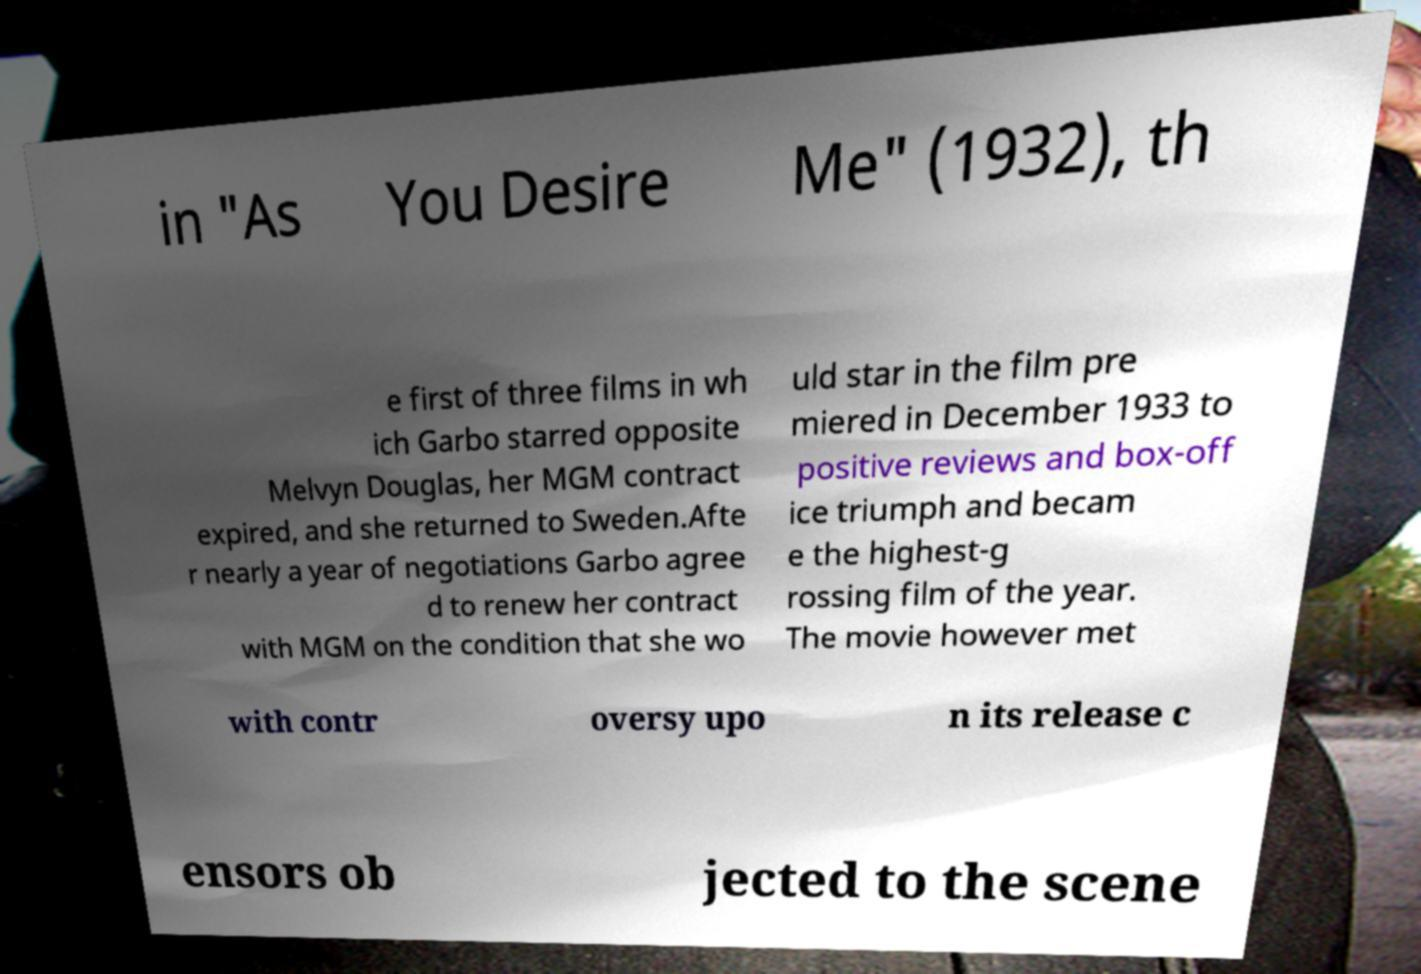Please read and relay the text visible in this image. What does it say? in "As You Desire Me" (1932), th e first of three films in wh ich Garbo starred opposite Melvyn Douglas, her MGM contract expired, and she returned to Sweden.Afte r nearly a year of negotiations Garbo agree d to renew her contract with MGM on the condition that she wo uld star in the film pre miered in December 1933 to positive reviews and box-off ice triumph and becam e the highest-g rossing film of the year. The movie however met with contr oversy upo n its release c ensors ob jected to the scene 